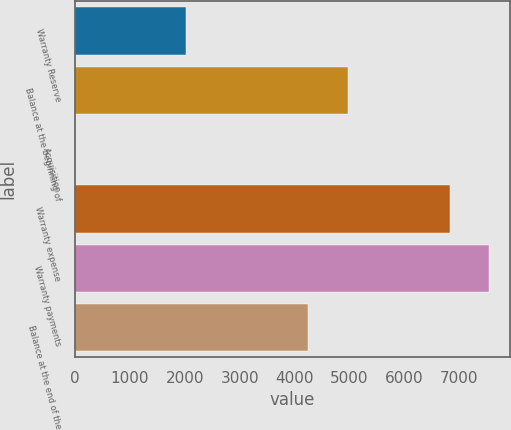<chart> <loc_0><loc_0><loc_500><loc_500><bar_chart><fcel>Warranty Reserve<fcel>Balance at the beginning of<fcel>Acquisition<fcel>Warranty expense<fcel>Warranty payments<fcel>Balance at the end of the<nl><fcel>2012<fcel>4970.86<fcel>0.39<fcel>6828<fcel>7546.86<fcel>4252<nl></chart> 